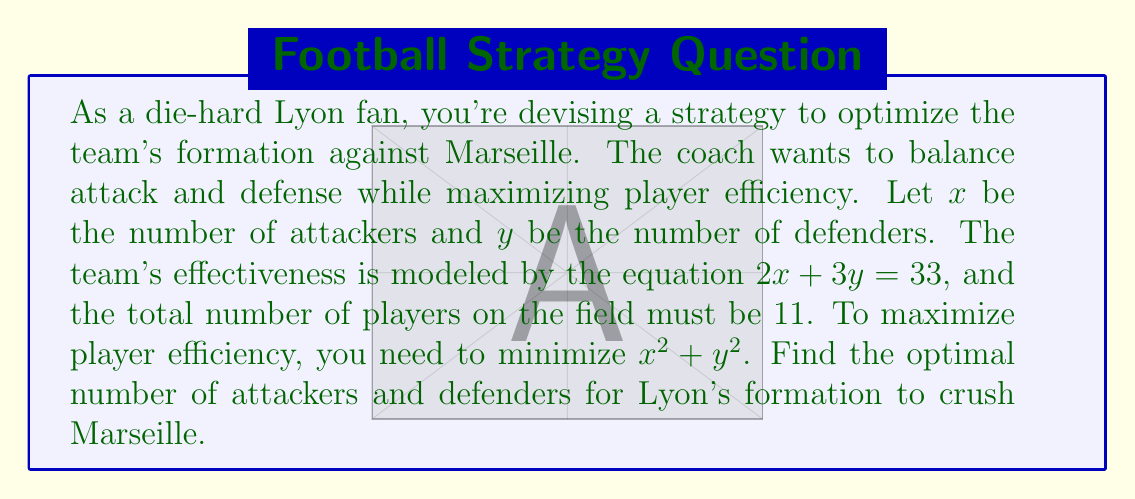Can you answer this question? Let's approach this step-by-step:

1) We have two constraints:
   $2x + 3y = 33$ (team effectiveness)
   $x + y = 11$ (total players)

2) We need to minimize $x^2 + y^2$

3) From the second equation, we can express $y$ in terms of $x$:
   $y = 11 - x$

4) Substitute this into the first equation:
   $2x + 3(11 - x) = 33$
   $2x + 33 - 3x = 33$
   $-x + 33 = 33$
   $-x = 0$
   $x = 5$

5) Now we can find $y$:
   $y = 11 - x = 11 - 5 = 6$

6) To verify this is indeed the minimum, we can use the method of Lagrange multipliers or observe that $x^2 + y^2$ is minimized when $x$ and $y$ are as close as possible while satisfying the constraints.

Therefore, the optimal formation for Lyon is 5 attackers and 6 defenders.
Answer: The optimal formation for Lyon is 5 attackers and 6 defenders. 